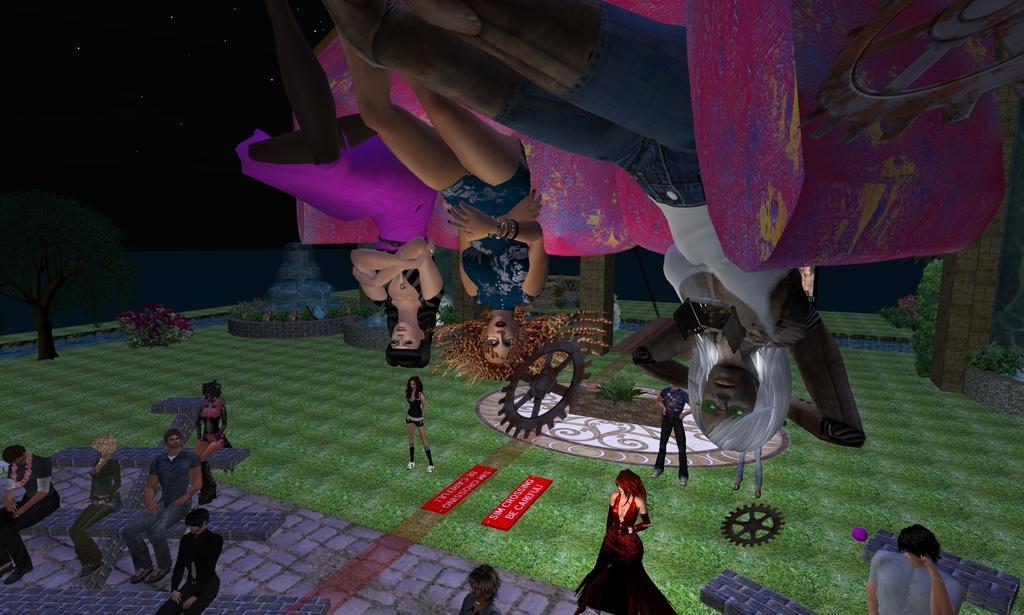Please provide a concise description of this image. This is an animation and here we can see many people standing and sitting and there are trees, plants and we can see a fountain, wheels, pillars and at the bottom, we can see some objects on the ground. 